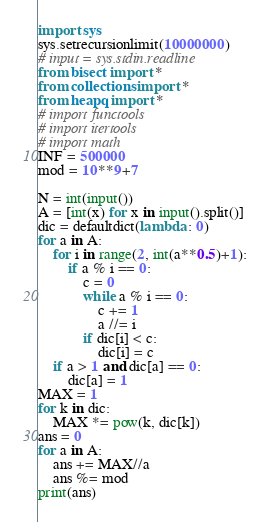Convert code to text. <code><loc_0><loc_0><loc_500><loc_500><_Python_>import sys
sys.setrecursionlimit(10000000)
# input = sys.stdin.readline
from bisect import *
from collections import *
from heapq import *
# import functools
# import itertools
# import math
INF = 500000
mod = 10**9+7

N = int(input())
A = [int(x) for x in input().split()]
dic = defaultdict(lambda : 0)
for a in A:
    for i in range(2, int(a**0.5)+1):
        if a % i == 0:
            c = 0
            while a % i == 0:
                c += 1
                a //= i
            if dic[i] < c:
                dic[i] = c
    if a > 1 and dic[a] == 0:
        dic[a] = 1
MAX = 1
for k in dic:
    MAX *= pow(k, dic[k])
ans = 0
for a in A:
    ans += MAX//a
    ans %= mod
print(ans)
</code> 